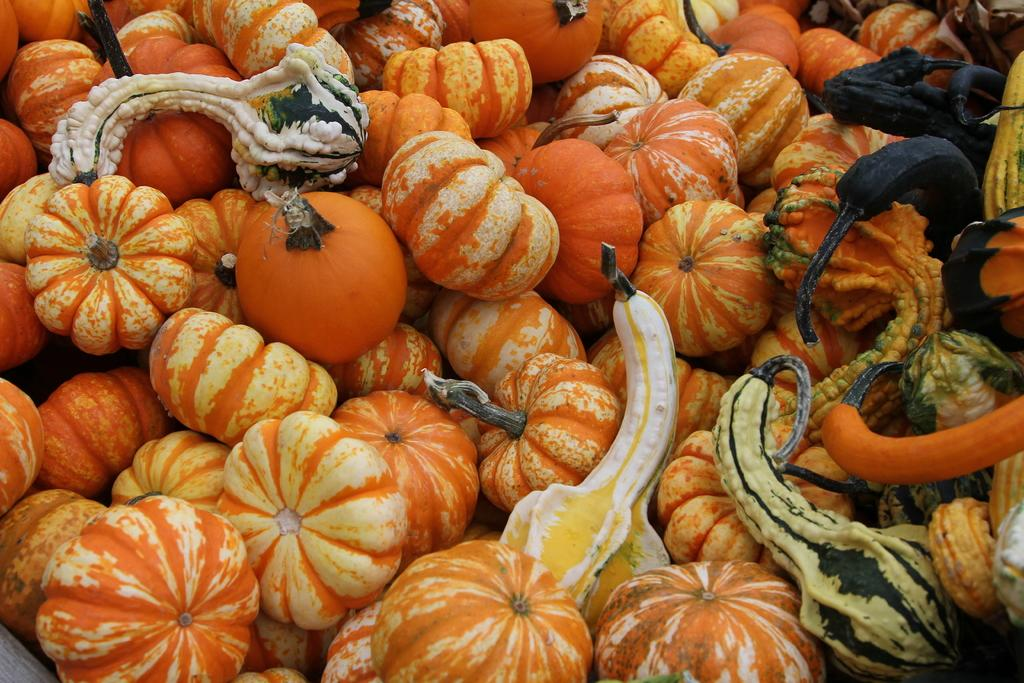What types of vegetables are in the foreground of the image? There are pumpkins and squashes in the foreground of the image. What type of sheet is covering the pumpkins and squashes in the image? There is no sheet covering the pumpkins and squashes in the image; they are visible in the foreground. Can you tell me how many zebras are present in the image? There are no zebras present in the image; it features pumpkins and squashes. 